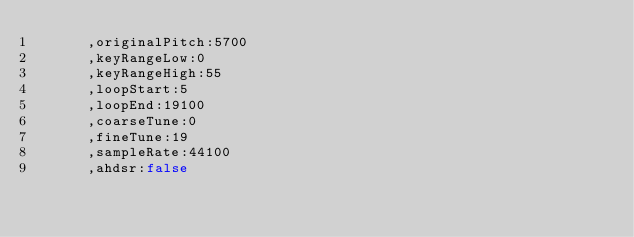<code> <loc_0><loc_0><loc_500><loc_500><_JavaScript_>			,originalPitch:5700
			,keyRangeLow:0
			,keyRangeHigh:55
			,loopStart:5
			,loopEnd:19100
			,coarseTune:0
			,fineTune:19
			,sampleRate:44100
			,ahdsr:false</code> 